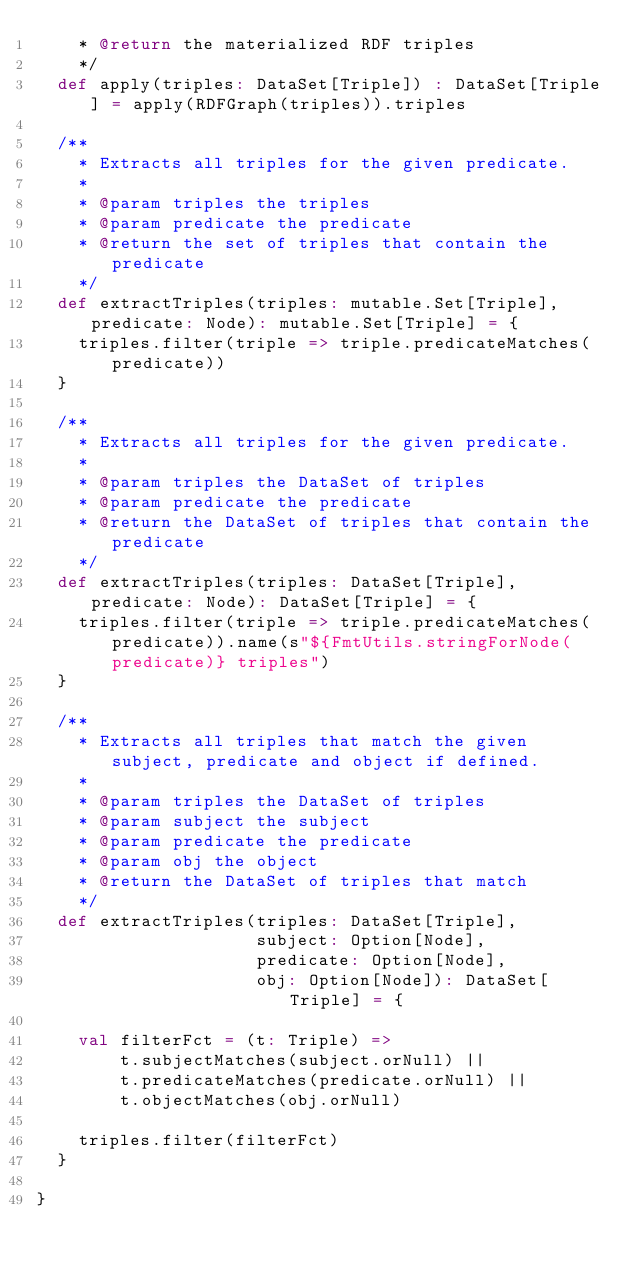Convert code to text. <code><loc_0><loc_0><loc_500><loc_500><_Scala_>    * @return the materialized RDF triples
    */
  def apply(triples: DataSet[Triple]) : DataSet[Triple] = apply(RDFGraph(triples)).triples

  /**
    * Extracts all triples for the given predicate.
    *
    * @param triples the triples
    * @param predicate the predicate
    * @return the set of triples that contain the predicate
    */
  def extractTriples(triples: mutable.Set[Triple], predicate: Node): mutable.Set[Triple] = {
    triples.filter(triple => triple.predicateMatches(predicate))
  }

  /**
    * Extracts all triples for the given predicate.
    *
    * @param triples the DataSet of triples
    * @param predicate the predicate
    * @return the DataSet of triples that contain the predicate
    */
  def extractTriples(triples: DataSet[Triple], predicate: Node): DataSet[Triple] = {
    triples.filter(triple => triple.predicateMatches(predicate)).name(s"${FmtUtils.stringForNode(predicate)} triples")
  }

  /**
    * Extracts all triples that match the given subject, predicate and object if defined.
    *
    * @param triples the DataSet of triples
    * @param subject the subject
    * @param predicate the predicate
    * @param obj the object
    * @return the DataSet of triples that match
    */
  def extractTriples(triples: DataSet[Triple],
                     subject: Option[Node],
                     predicate: Option[Node],
                     obj: Option[Node]): DataSet[Triple] = {

    val filterFct = (t: Triple) =>
        t.subjectMatches(subject.orNull) ||
        t.predicateMatches(predicate.orNull) ||
        t.objectMatches(obj.orNull)

    triples.filter(filterFct)
  }

}
</code> 